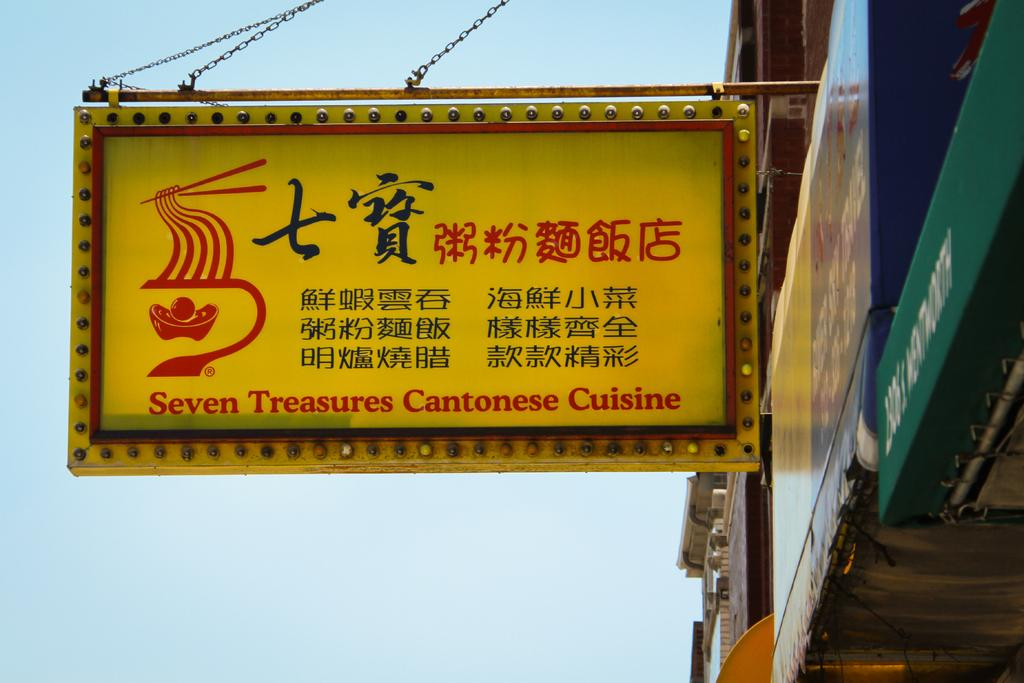<image>
Give a short and clear explanation of the subsequent image. The signboard for Seven Treasures Cantonese Cuisine hanging from the building. 